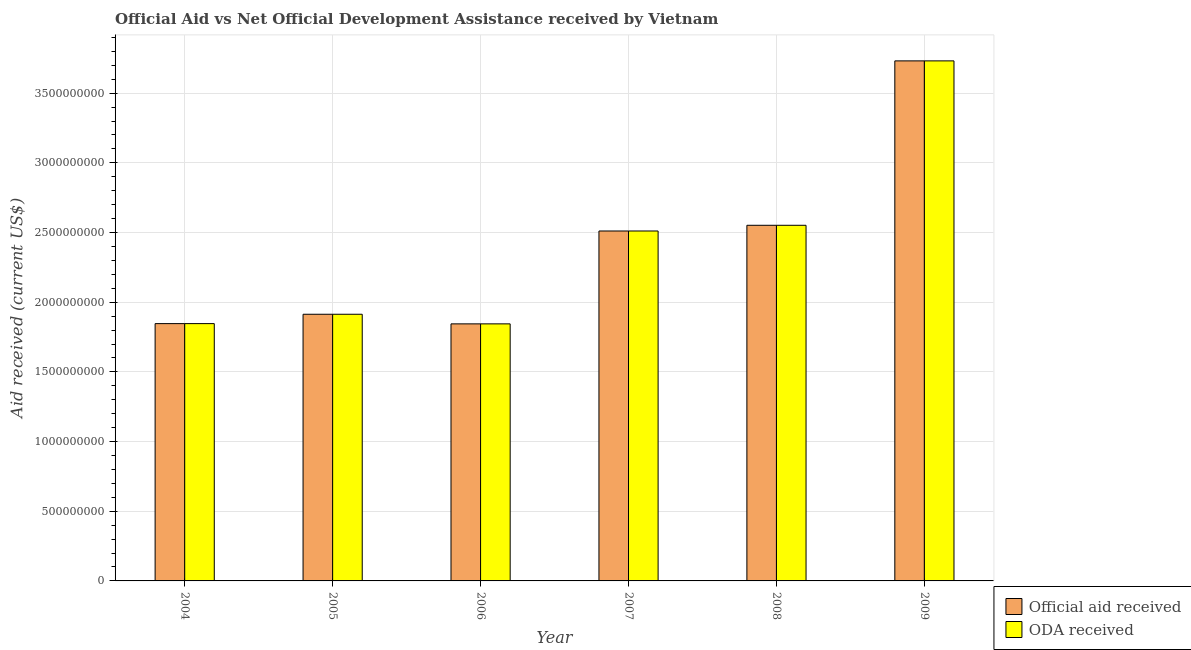How many different coloured bars are there?
Give a very brief answer. 2. How many bars are there on the 5th tick from the left?
Make the answer very short. 2. How many bars are there on the 2nd tick from the right?
Provide a succinct answer. 2. What is the label of the 3rd group of bars from the left?
Give a very brief answer. 2006. What is the oda received in 2004?
Give a very brief answer. 1.85e+09. Across all years, what is the maximum oda received?
Offer a very short reply. 3.73e+09. Across all years, what is the minimum official aid received?
Your answer should be compact. 1.84e+09. What is the total official aid received in the graph?
Give a very brief answer. 1.44e+1. What is the difference between the official aid received in 2006 and that in 2007?
Your response must be concise. -6.66e+08. What is the difference between the oda received in 2006 and the official aid received in 2007?
Keep it short and to the point. -6.66e+08. What is the average official aid received per year?
Provide a short and direct response. 2.40e+09. In the year 2009, what is the difference between the oda received and official aid received?
Provide a short and direct response. 0. What is the ratio of the oda received in 2005 to that in 2008?
Provide a succinct answer. 0.75. Is the oda received in 2007 less than that in 2008?
Provide a succinct answer. Yes. Is the difference between the official aid received in 2005 and 2009 greater than the difference between the oda received in 2005 and 2009?
Ensure brevity in your answer.  No. What is the difference between the highest and the second highest oda received?
Provide a short and direct response. 1.18e+09. What is the difference between the highest and the lowest oda received?
Offer a terse response. 1.89e+09. In how many years, is the oda received greater than the average oda received taken over all years?
Your answer should be compact. 3. Is the sum of the official aid received in 2006 and 2008 greater than the maximum oda received across all years?
Your answer should be compact. Yes. What does the 1st bar from the left in 2004 represents?
Your response must be concise. Official aid received. What does the 2nd bar from the right in 2009 represents?
Your answer should be compact. Official aid received. Are all the bars in the graph horizontal?
Your answer should be very brief. No. How many years are there in the graph?
Offer a very short reply. 6. Does the graph contain any zero values?
Give a very brief answer. No. How many legend labels are there?
Offer a terse response. 2. What is the title of the graph?
Your answer should be very brief. Official Aid vs Net Official Development Assistance received by Vietnam . What is the label or title of the X-axis?
Make the answer very short. Year. What is the label or title of the Y-axis?
Offer a terse response. Aid received (current US$). What is the Aid received (current US$) in Official aid received in 2004?
Make the answer very short. 1.85e+09. What is the Aid received (current US$) in ODA received in 2004?
Provide a short and direct response. 1.85e+09. What is the Aid received (current US$) in Official aid received in 2005?
Give a very brief answer. 1.91e+09. What is the Aid received (current US$) of ODA received in 2005?
Your response must be concise. 1.91e+09. What is the Aid received (current US$) in Official aid received in 2006?
Your response must be concise. 1.84e+09. What is the Aid received (current US$) in ODA received in 2006?
Ensure brevity in your answer.  1.84e+09. What is the Aid received (current US$) in Official aid received in 2007?
Your answer should be very brief. 2.51e+09. What is the Aid received (current US$) in ODA received in 2007?
Provide a succinct answer. 2.51e+09. What is the Aid received (current US$) of Official aid received in 2008?
Your answer should be compact. 2.55e+09. What is the Aid received (current US$) in ODA received in 2008?
Offer a terse response. 2.55e+09. What is the Aid received (current US$) of Official aid received in 2009?
Make the answer very short. 3.73e+09. What is the Aid received (current US$) in ODA received in 2009?
Your answer should be very brief. 3.73e+09. Across all years, what is the maximum Aid received (current US$) of Official aid received?
Offer a very short reply. 3.73e+09. Across all years, what is the maximum Aid received (current US$) in ODA received?
Your response must be concise. 3.73e+09. Across all years, what is the minimum Aid received (current US$) in Official aid received?
Make the answer very short. 1.84e+09. Across all years, what is the minimum Aid received (current US$) in ODA received?
Your response must be concise. 1.84e+09. What is the total Aid received (current US$) in Official aid received in the graph?
Your answer should be very brief. 1.44e+1. What is the total Aid received (current US$) of ODA received in the graph?
Your answer should be very brief. 1.44e+1. What is the difference between the Aid received (current US$) in Official aid received in 2004 and that in 2005?
Provide a succinct answer. -6.72e+07. What is the difference between the Aid received (current US$) of ODA received in 2004 and that in 2005?
Provide a short and direct response. -6.72e+07. What is the difference between the Aid received (current US$) of Official aid received in 2004 and that in 2006?
Your answer should be compact. 1.77e+06. What is the difference between the Aid received (current US$) in ODA received in 2004 and that in 2006?
Provide a short and direct response. 1.77e+06. What is the difference between the Aid received (current US$) of Official aid received in 2004 and that in 2007?
Provide a short and direct response. -6.65e+08. What is the difference between the Aid received (current US$) in ODA received in 2004 and that in 2007?
Provide a succinct answer. -6.65e+08. What is the difference between the Aid received (current US$) in Official aid received in 2004 and that in 2008?
Ensure brevity in your answer.  -7.06e+08. What is the difference between the Aid received (current US$) of ODA received in 2004 and that in 2008?
Offer a very short reply. -7.06e+08. What is the difference between the Aid received (current US$) in Official aid received in 2004 and that in 2009?
Provide a succinct answer. -1.89e+09. What is the difference between the Aid received (current US$) of ODA received in 2004 and that in 2009?
Offer a very short reply. -1.89e+09. What is the difference between the Aid received (current US$) of Official aid received in 2005 and that in 2006?
Ensure brevity in your answer.  6.89e+07. What is the difference between the Aid received (current US$) in ODA received in 2005 and that in 2006?
Offer a very short reply. 6.89e+07. What is the difference between the Aid received (current US$) in Official aid received in 2005 and that in 2007?
Ensure brevity in your answer.  -5.97e+08. What is the difference between the Aid received (current US$) in ODA received in 2005 and that in 2007?
Provide a short and direct response. -5.97e+08. What is the difference between the Aid received (current US$) in Official aid received in 2005 and that in 2008?
Offer a terse response. -6.38e+08. What is the difference between the Aid received (current US$) in ODA received in 2005 and that in 2008?
Your answer should be very brief. -6.38e+08. What is the difference between the Aid received (current US$) of Official aid received in 2005 and that in 2009?
Offer a very short reply. -1.82e+09. What is the difference between the Aid received (current US$) in ODA received in 2005 and that in 2009?
Provide a succinct answer. -1.82e+09. What is the difference between the Aid received (current US$) of Official aid received in 2006 and that in 2007?
Offer a very short reply. -6.66e+08. What is the difference between the Aid received (current US$) of ODA received in 2006 and that in 2007?
Give a very brief answer. -6.66e+08. What is the difference between the Aid received (current US$) in Official aid received in 2006 and that in 2008?
Offer a very short reply. -7.07e+08. What is the difference between the Aid received (current US$) of ODA received in 2006 and that in 2008?
Your answer should be very brief. -7.07e+08. What is the difference between the Aid received (current US$) of Official aid received in 2006 and that in 2009?
Keep it short and to the point. -1.89e+09. What is the difference between the Aid received (current US$) in ODA received in 2006 and that in 2009?
Give a very brief answer. -1.89e+09. What is the difference between the Aid received (current US$) of Official aid received in 2007 and that in 2008?
Offer a terse response. -4.10e+07. What is the difference between the Aid received (current US$) of ODA received in 2007 and that in 2008?
Provide a succinct answer. -4.10e+07. What is the difference between the Aid received (current US$) of Official aid received in 2007 and that in 2009?
Keep it short and to the point. -1.22e+09. What is the difference between the Aid received (current US$) of ODA received in 2007 and that in 2009?
Give a very brief answer. -1.22e+09. What is the difference between the Aid received (current US$) of Official aid received in 2008 and that in 2009?
Ensure brevity in your answer.  -1.18e+09. What is the difference between the Aid received (current US$) in ODA received in 2008 and that in 2009?
Provide a succinct answer. -1.18e+09. What is the difference between the Aid received (current US$) of Official aid received in 2004 and the Aid received (current US$) of ODA received in 2005?
Provide a short and direct response. -6.72e+07. What is the difference between the Aid received (current US$) of Official aid received in 2004 and the Aid received (current US$) of ODA received in 2006?
Keep it short and to the point. 1.77e+06. What is the difference between the Aid received (current US$) of Official aid received in 2004 and the Aid received (current US$) of ODA received in 2007?
Give a very brief answer. -6.65e+08. What is the difference between the Aid received (current US$) of Official aid received in 2004 and the Aid received (current US$) of ODA received in 2008?
Your response must be concise. -7.06e+08. What is the difference between the Aid received (current US$) of Official aid received in 2004 and the Aid received (current US$) of ODA received in 2009?
Ensure brevity in your answer.  -1.89e+09. What is the difference between the Aid received (current US$) in Official aid received in 2005 and the Aid received (current US$) in ODA received in 2006?
Offer a very short reply. 6.89e+07. What is the difference between the Aid received (current US$) in Official aid received in 2005 and the Aid received (current US$) in ODA received in 2007?
Your answer should be compact. -5.97e+08. What is the difference between the Aid received (current US$) in Official aid received in 2005 and the Aid received (current US$) in ODA received in 2008?
Your answer should be compact. -6.38e+08. What is the difference between the Aid received (current US$) in Official aid received in 2005 and the Aid received (current US$) in ODA received in 2009?
Keep it short and to the point. -1.82e+09. What is the difference between the Aid received (current US$) in Official aid received in 2006 and the Aid received (current US$) in ODA received in 2007?
Give a very brief answer. -6.66e+08. What is the difference between the Aid received (current US$) of Official aid received in 2006 and the Aid received (current US$) of ODA received in 2008?
Give a very brief answer. -7.07e+08. What is the difference between the Aid received (current US$) in Official aid received in 2006 and the Aid received (current US$) in ODA received in 2009?
Give a very brief answer. -1.89e+09. What is the difference between the Aid received (current US$) of Official aid received in 2007 and the Aid received (current US$) of ODA received in 2008?
Provide a short and direct response. -4.10e+07. What is the difference between the Aid received (current US$) in Official aid received in 2007 and the Aid received (current US$) in ODA received in 2009?
Keep it short and to the point. -1.22e+09. What is the difference between the Aid received (current US$) in Official aid received in 2008 and the Aid received (current US$) in ODA received in 2009?
Make the answer very short. -1.18e+09. What is the average Aid received (current US$) of Official aid received per year?
Provide a succinct answer. 2.40e+09. What is the average Aid received (current US$) of ODA received per year?
Your answer should be compact. 2.40e+09. In the year 2004, what is the difference between the Aid received (current US$) of Official aid received and Aid received (current US$) of ODA received?
Offer a very short reply. 0. In the year 2005, what is the difference between the Aid received (current US$) in Official aid received and Aid received (current US$) in ODA received?
Your response must be concise. 0. In the year 2006, what is the difference between the Aid received (current US$) in Official aid received and Aid received (current US$) in ODA received?
Offer a terse response. 0. What is the ratio of the Aid received (current US$) of Official aid received in 2004 to that in 2005?
Keep it short and to the point. 0.96. What is the ratio of the Aid received (current US$) in ODA received in 2004 to that in 2005?
Offer a very short reply. 0.96. What is the ratio of the Aid received (current US$) in Official aid received in 2004 to that in 2006?
Your response must be concise. 1. What is the ratio of the Aid received (current US$) in ODA received in 2004 to that in 2006?
Keep it short and to the point. 1. What is the ratio of the Aid received (current US$) of Official aid received in 2004 to that in 2007?
Give a very brief answer. 0.74. What is the ratio of the Aid received (current US$) of ODA received in 2004 to that in 2007?
Your answer should be compact. 0.74. What is the ratio of the Aid received (current US$) of Official aid received in 2004 to that in 2008?
Offer a terse response. 0.72. What is the ratio of the Aid received (current US$) in ODA received in 2004 to that in 2008?
Your answer should be very brief. 0.72. What is the ratio of the Aid received (current US$) in Official aid received in 2004 to that in 2009?
Ensure brevity in your answer.  0.49. What is the ratio of the Aid received (current US$) in ODA received in 2004 to that in 2009?
Ensure brevity in your answer.  0.49. What is the ratio of the Aid received (current US$) in Official aid received in 2005 to that in 2006?
Provide a short and direct response. 1.04. What is the ratio of the Aid received (current US$) in ODA received in 2005 to that in 2006?
Offer a very short reply. 1.04. What is the ratio of the Aid received (current US$) of Official aid received in 2005 to that in 2007?
Ensure brevity in your answer.  0.76. What is the ratio of the Aid received (current US$) in ODA received in 2005 to that in 2007?
Keep it short and to the point. 0.76. What is the ratio of the Aid received (current US$) of Official aid received in 2005 to that in 2008?
Your response must be concise. 0.75. What is the ratio of the Aid received (current US$) of ODA received in 2005 to that in 2008?
Make the answer very short. 0.75. What is the ratio of the Aid received (current US$) in Official aid received in 2005 to that in 2009?
Provide a short and direct response. 0.51. What is the ratio of the Aid received (current US$) of ODA received in 2005 to that in 2009?
Your answer should be compact. 0.51. What is the ratio of the Aid received (current US$) in Official aid received in 2006 to that in 2007?
Keep it short and to the point. 0.73. What is the ratio of the Aid received (current US$) in ODA received in 2006 to that in 2007?
Keep it short and to the point. 0.73. What is the ratio of the Aid received (current US$) of Official aid received in 2006 to that in 2008?
Ensure brevity in your answer.  0.72. What is the ratio of the Aid received (current US$) of ODA received in 2006 to that in 2008?
Your answer should be compact. 0.72. What is the ratio of the Aid received (current US$) of Official aid received in 2006 to that in 2009?
Your answer should be compact. 0.49. What is the ratio of the Aid received (current US$) in ODA received in 2006 to that in 2009?
Your answer should be very brief. 0.49. What is the ratio of the Aid received (current US$) of Official aid received in 2007 to that in 2008?
Provide a short and direct response. 0.98. What is the ratio of the Aid received (current US$) of ODA received in 2007 to that in 2008?
Provide a short and direct response. 0.98. What is the ratio of the Aid received (current US$) of Official aid received in 2007 to that in 2009?
Ensure brevity in your answer.  0.67. What is the ratio of the Aid received (current US$) of ODA received in 2007 to that in 2009?
Your answer should be compact. 0.67. What is the ratio of the Aid received (current US$) of Official aid received in 2008 to that in 2009?
Provide a succinct answer. 0.68. What is the ratio of the Aid received (current US$) of ODA received in 2008 to that in 2009?
Give a very brief answer. 0.68. What is the difference between the highest and the second highest Aid received (current US$) of Official aid received?
Offer a very short reply. 1.18e+09. What is the difference between the highest and the second highest Aid received (current US$) in ODA received?
Ensure brevity in your answer.  1.18e+09. What is the difference between the highest and the lowest Aid received (current US$) in Official aid received?
Your answer should be compact. 1.89e+09. What is the difference between the highest and the lowest Aid received (current US$) in ODA received?
Offer a very short reply. 1.89e+09. 